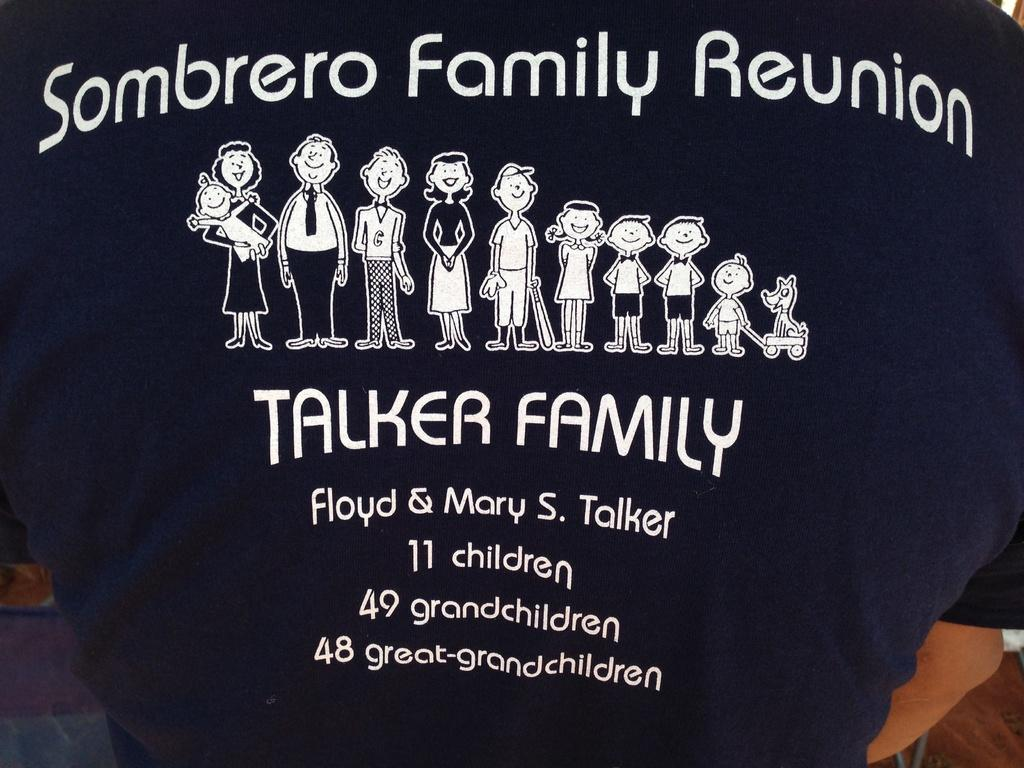What is the main subject of the image? There is a person standing in the center of the image. What is the person wearing in the image? The person is wearing a black t-shirt. Can you describe the t-shirt further? Yes, there is text and images on the t-shirt. What type of metal can be seen on the person's badge in the image? There is no badge present in the image, so it is not possible to determine the type of metal used. 